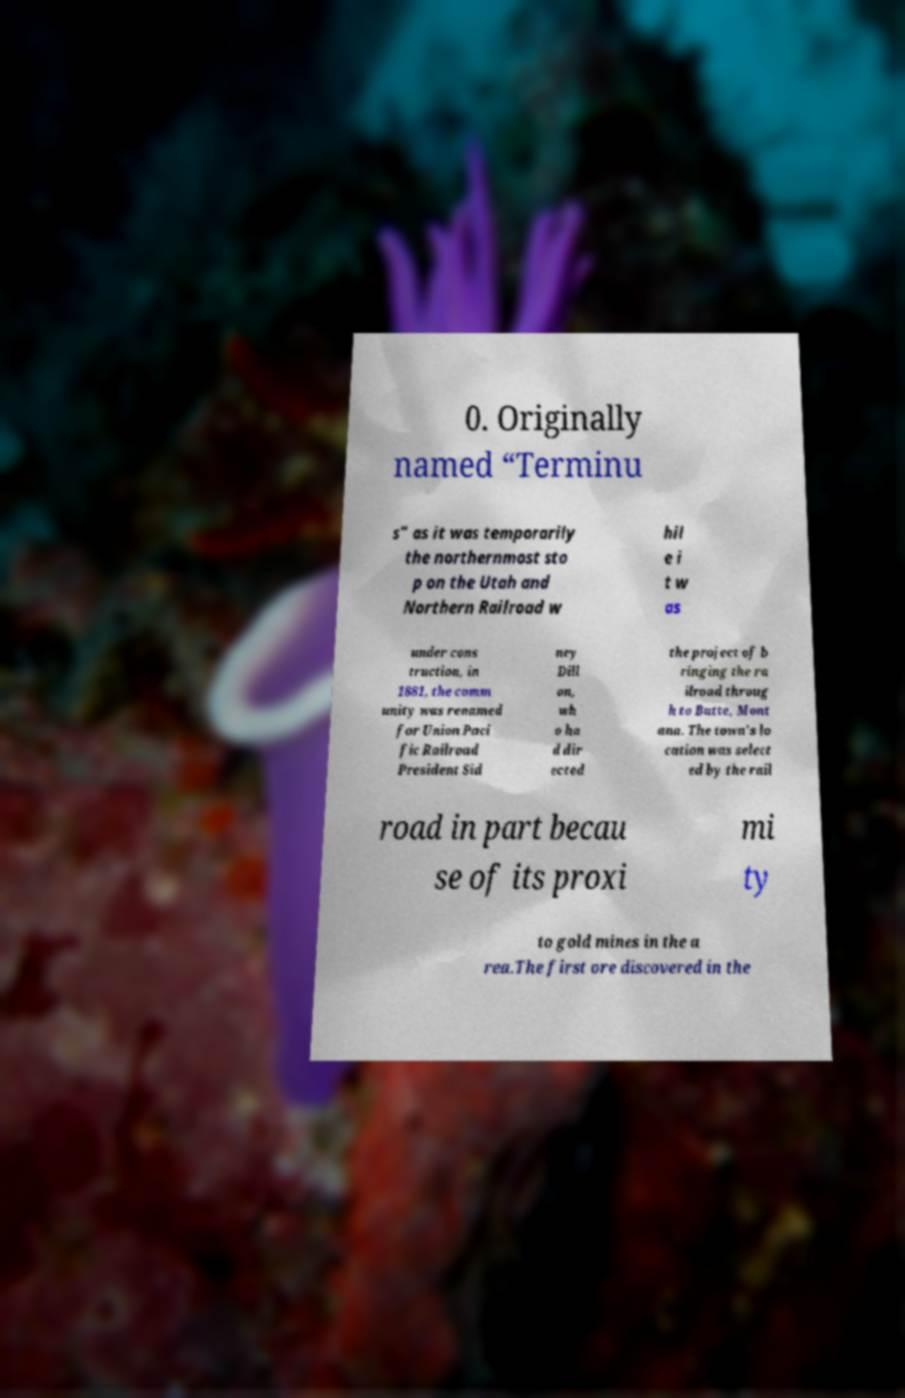Could you assist in decoding the text presented in this image and type it out clearly? 0. Originally named “Terminu s” as it was temporarily the northernmost sto p on the Utah and Northern Railroad w hil e i t w as under cons truction, in 1881, the comm unity was renamed for Union Paci fic Railroad President Sid ney Dill on, wh o ha d dir ected the project of b ringing the ra ilroad throug h to Butte, Mont ana. The town's lo cation was select ed by the rail road in part becau se of its proxi mi ty to gold mines in the a rea.The first ore discovered in the 